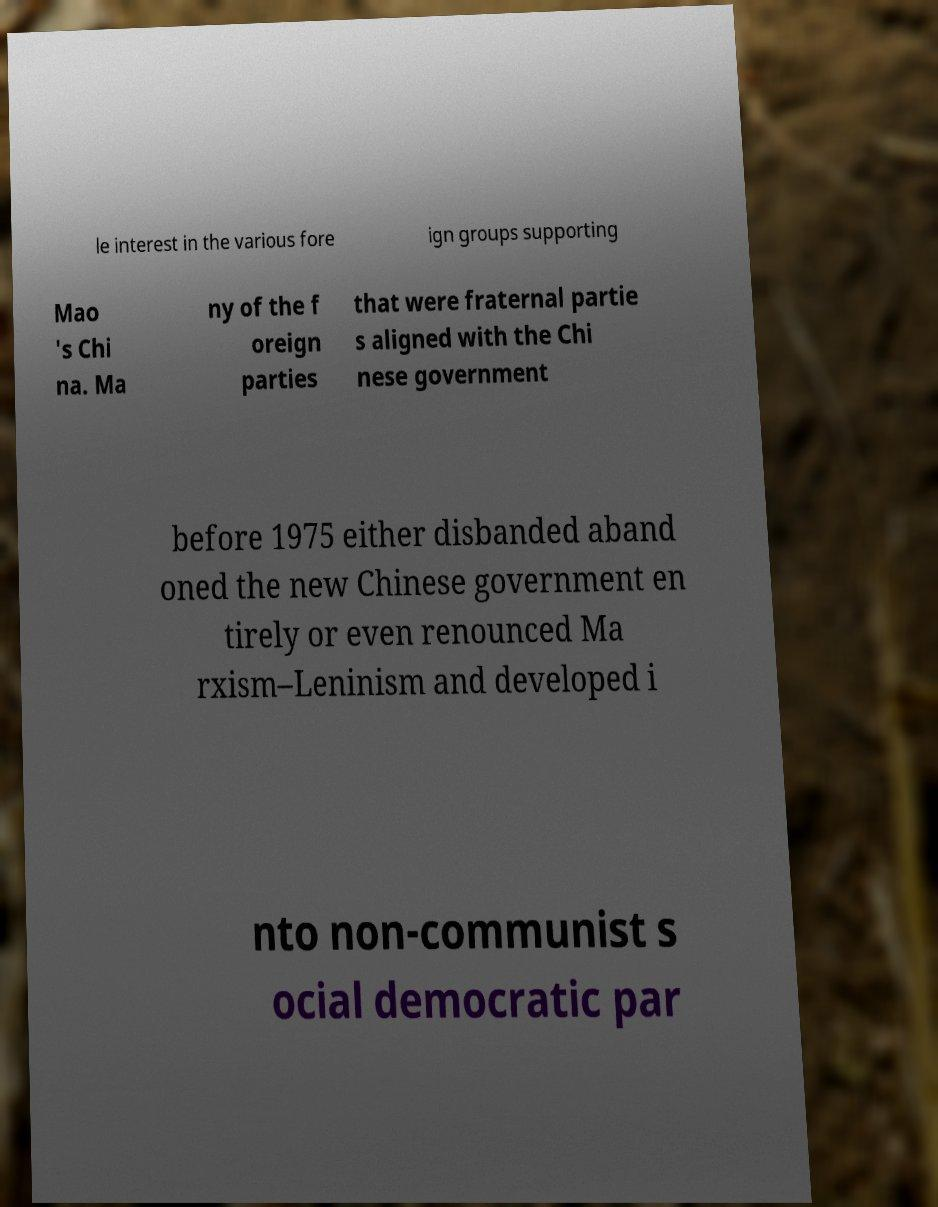Can you read and provide the text displayed in the image?This photo seems to have some interesting text. Can you extract and type it out for me? le interest in the various fore ign groups supporting Mao 's Chi na. Ma ny of the f oreign parties that were fraternal partie s aligned with the Chi nese government before 1975 either disbanded aband oned the new Chinese government en tirely or even renounced Ma rxism–Leninism and developed i nto non-communist s ocial democratic par 